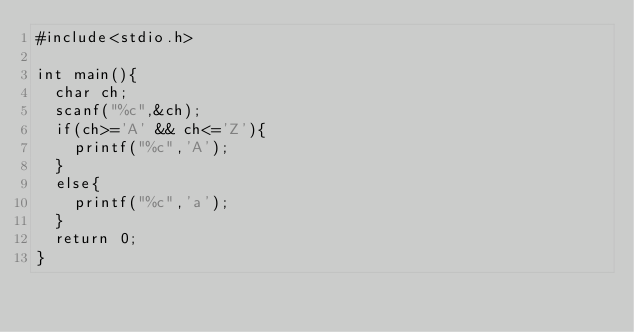Convert code to text. <code><loc_0><loc_0><loc_500><loc_500><_C_>#include<stdio.h>

int main(){
  char ch;
  scanf("%c",&ch);
  if(ch>='A' && ch<='Z'){
    printf("%c",'A');
  }
  else{
    printf("%c",'a');
  }
  return 0;
}</code> 